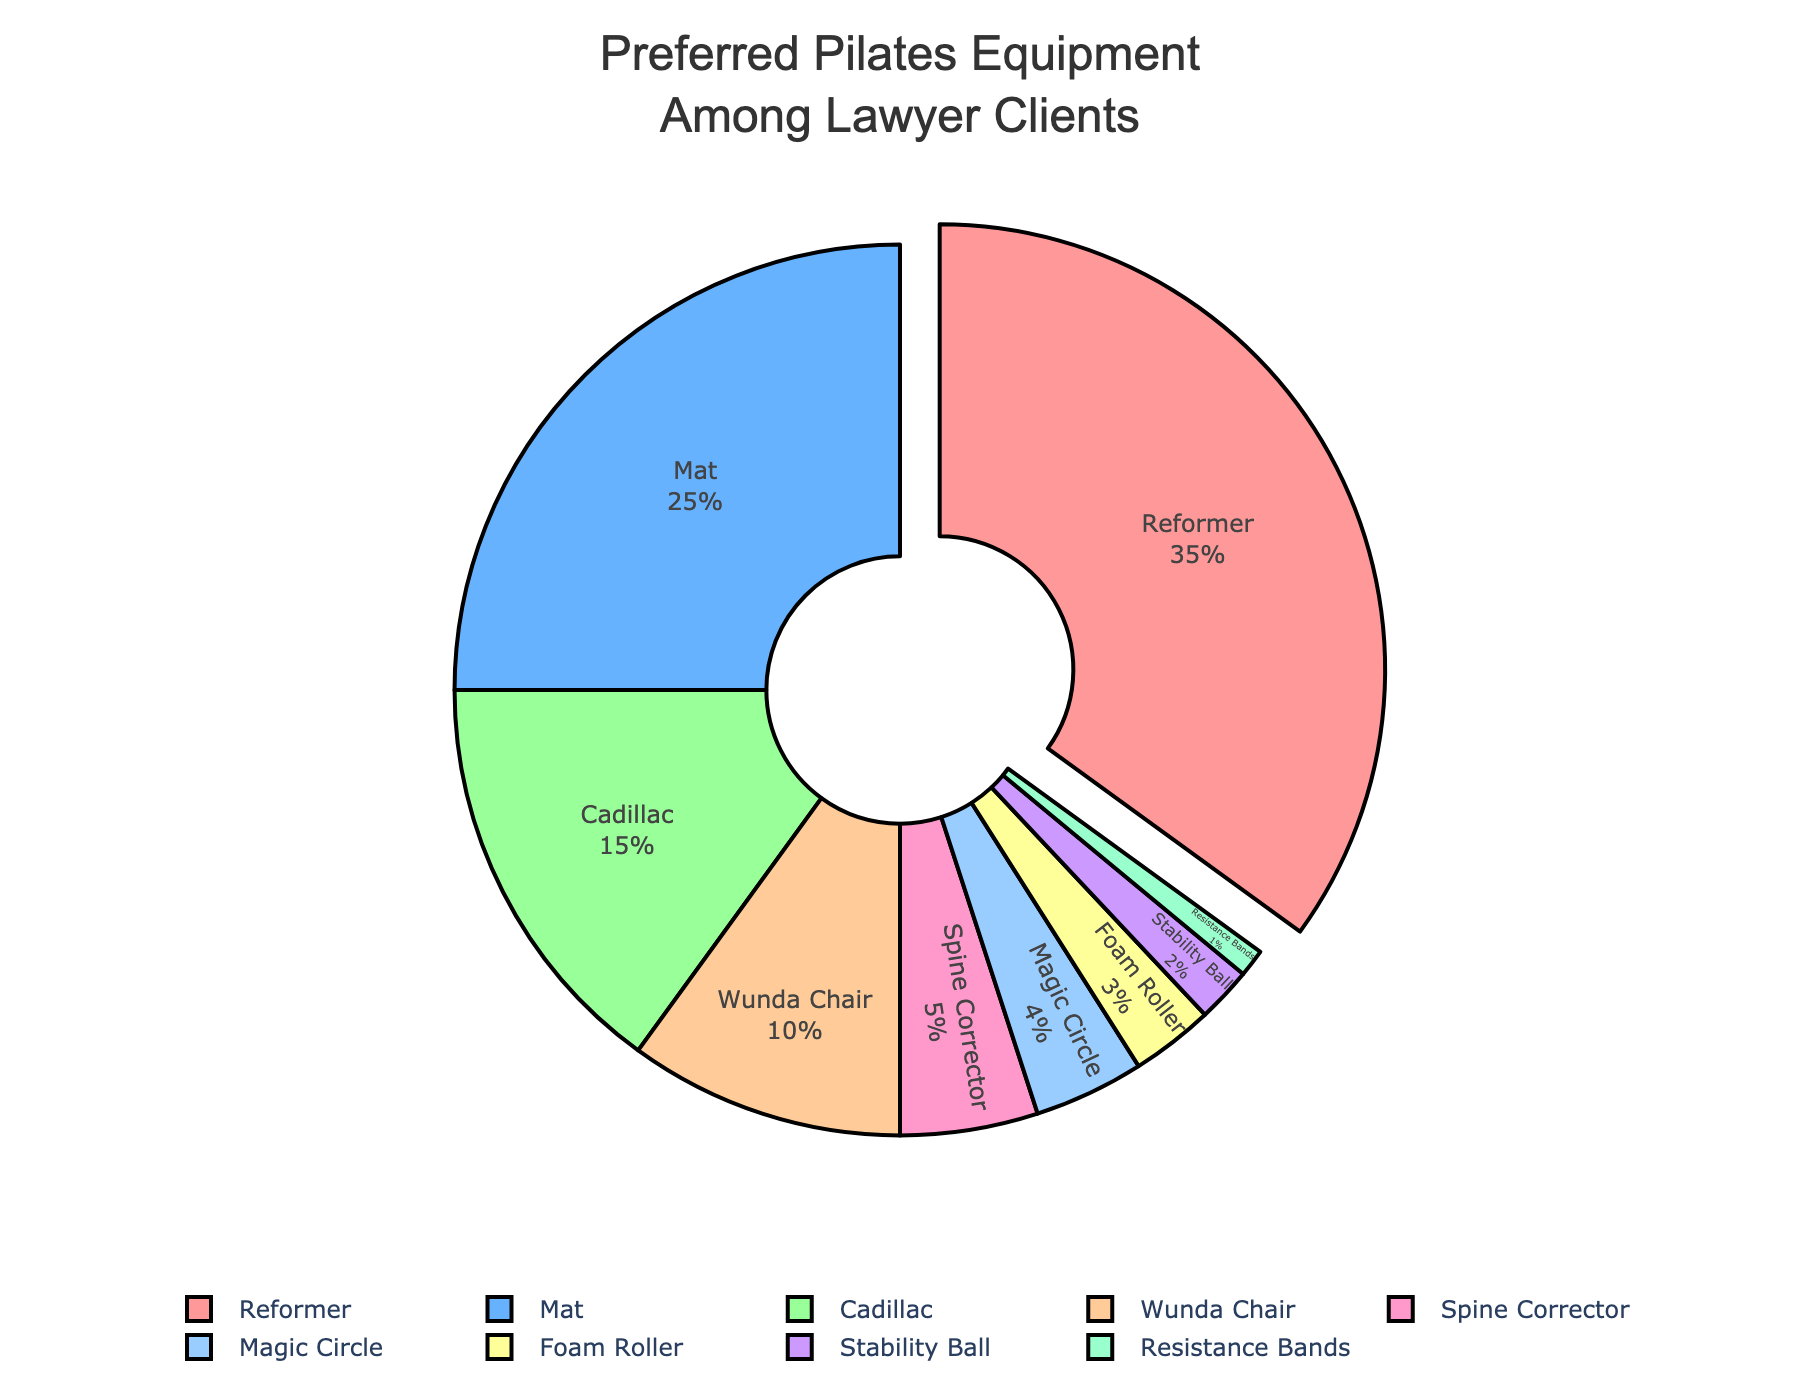Which Pilates equipment do lawyer clients prefer the most? The pie chart shows the distribution percentages for different Pilates equipment. The slice of the pie chart with the largest percentage represents the most preferred equipment.
Answer: Reformer What is the combined percentage of lawyer clients who prefer the Stability Ball and the Resistance Bands? Adding the percentages for Stability Ball (2%) and Resistance Bands (1%) gives the combined percentage.
Answer: 3% How does the percentage preference for the Mat compare to the Cadillac? The pie chart shows the percentage for Mat as 25% and Cadillac as 15%. Mat is preferred by a higher percentage compared to the Cadillac.
Answer: Mat is preferred more than Cadillac Which equipment is the least preferred among lawyer clients, and what is its percentage? The pie chart segment with the smallest percentage indicates the least preferred equipment.
Answer: Resistance Bands, 1% What is the difference in the percentage between those who prefer the Reformer and those who prefer the Wunda Chair? The pie chart shows 35% for Reformer and 10% for Wunda Chair. Subtracting 10% from 35% gives the difference.
Answer: 25% What is the total percentage of lawyer clients who prefer Reformer, Mat, and Cadillac combined? Adding the percentages for Reformer (35%), Mat (25%), and Cadillac (15%) gives the total combined percentage.
Answer: 75% Which equipment preference is highlighted or pulled out in the pie chart? The pie chart visually pulls out the segment with the highest percentage to emphasize it.
Answer: Reformer How many types of Pilates equipment have a preference percentage less than 10%? By analyzing the pie chart, identify the slices with percentages less than 10%: Wunda Chair (10%), Spine Corrector (5%), Magic Circle (4%), Foam Roller (3%), Stability Ball (2%), and Resistance Bands (1%).
Answer: 6 What is the percentage difference between the least preferred and the most preferred equipment? The most preferred equipment is Reformer with 35%, and the least preferred is Resistance Bands with 1%. Subtract 1% from 35% for the difference.
Answer: 34% Compare the percentage of clients preferring the Magic Circle to those preferring the Spine Corrector. The pie chart shows the percentages for Magic Circle (4%) and Spine Corrector (5%). The Spine Corrector is preferred by a higher percentage.
Answer: Spine Corrector is preferred more than Magic Circle 